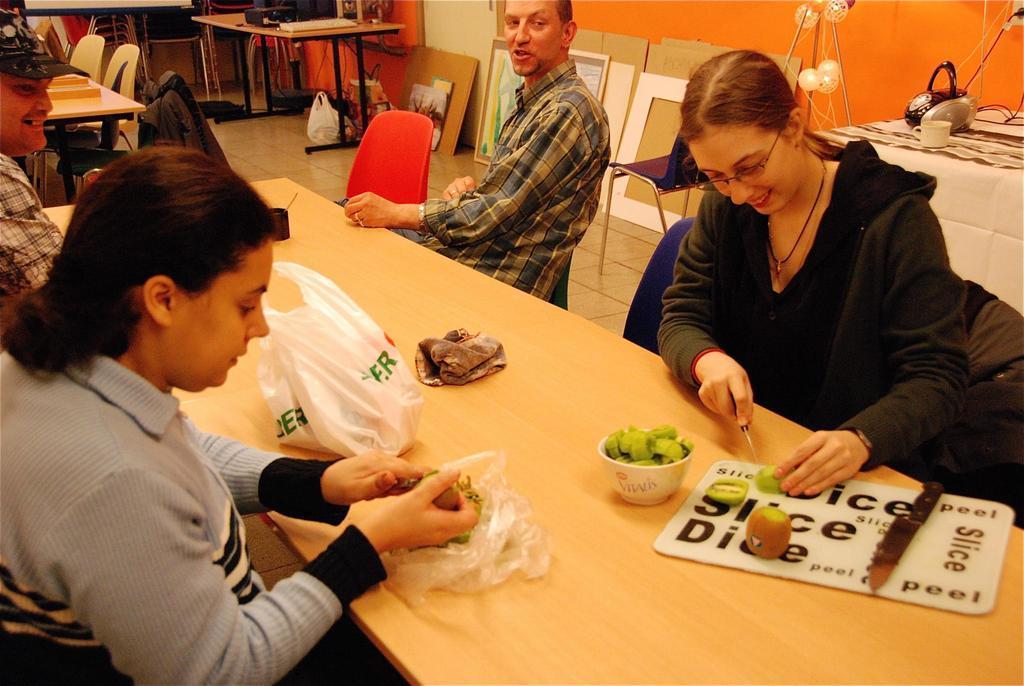Please provide a concise description of this image. It looks like a room there are group of people sitting around a table the woman is cutting Kiwi fruit and putting them into the bowl behind there is a white color table to the left side there are few other tables and there are some papers and some equipment on it, in the background there is an orange color wall. 